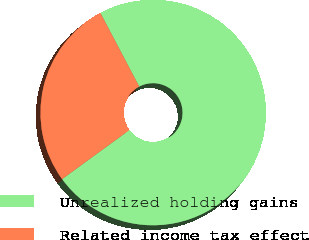<chart> <loc_0><loc_0><loc_500><loc_500><pie_chart><fcel>Unrealized holding gains<fcel>Related income tax effect<nl><fcel>72.7%<fcel>27.3%<nl></chart> 